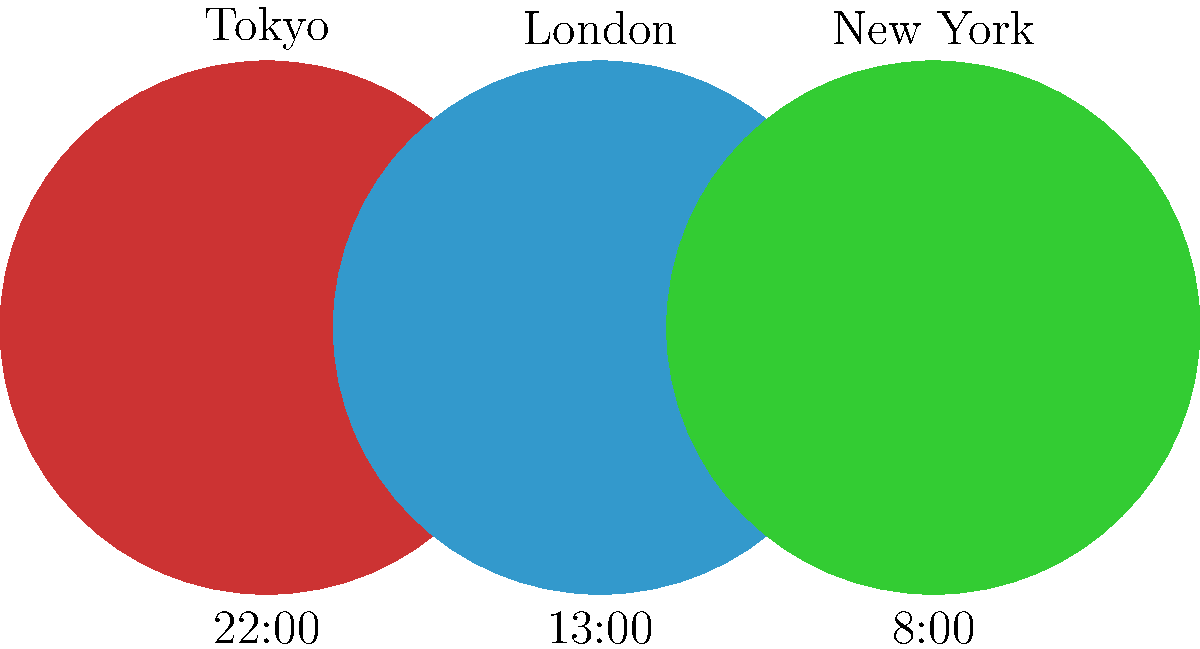As a travel journalist, you're planning a virtual interview with sources in Tokyo, London, and New York. Given the current times shown in the image, calculate the time in New York when it will be 9:00 AM the next day in Tokyo, considering that Tokyo doesn't observe Daylight Saving Time (DST), London is currently observing DST (UTC+1), and New York is also observing DST (UTC-4). Let's approach this step-by-step:

1) First, we need to determine the time differences between the cities:
   - Tokyo is 9 hours ahead of London (when London is observing DST)
   - London is 5 hours ahead of New York (when both are observing DST)
   - Therefore, Tokyo is 14 hours ahead of New York

2) Current times:
   - Tokyo: 22:00
   - London: 13:00
   - New York: 8:00

3) We need to find the time in New York when it's 9:00 AM the next day in Tokyo:
   - Hours to add to current Tokyo time: $24 - 22 + 9 = 11$ hours

4) Calculate the corresponding time change in New York:
   - Since Tokyo is 14 hours ahead, subtract 14 from 11:
   - $11 - 14 = -3$ hours

5) Apply this time change to the current New York time:
   - Current New York time: 8:00
   - Time change: -3 hours
   - $8:00 - 3:00 = 5:00$

Therefore, when it's 9:00 AM the next day in Tokyo, it will be 5:00 PM (17:00) the previous day in New York.
Answer: 5:00 PM 